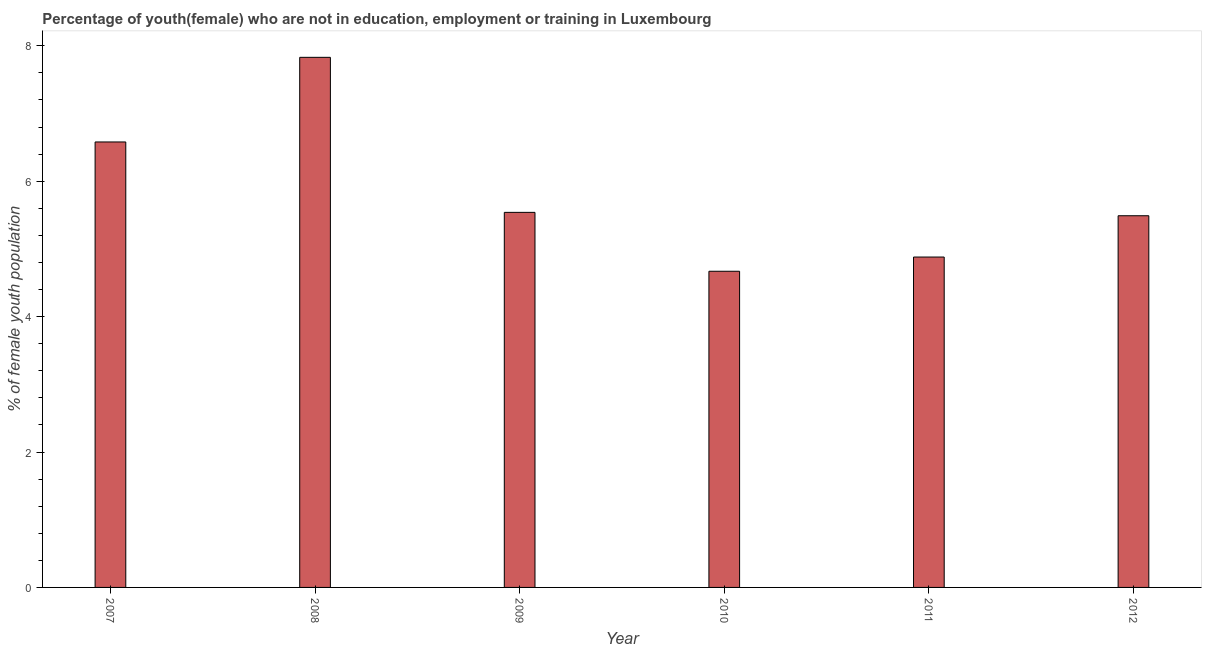Does the graph contain any zero values?
Provide a succinct answer. No. Does the graph contain grids?
Give a very brief answer. No. What is the title of the graph?
Your response must be concise. Percentage of youth(female) who are not in education, employment or training in Luxembourg. What is the label or title of the X-axis?
Offer a very short reply. Year. What is the label or title of the Y-axis?
Give a very brief answer. % of female youth population. What is the unemployed female youth population in 2007?
Provide a short and direct response. 6.58. Across all years, what is the maximum unemployed female youth population?
Offer a terse response. 7.83. Across all years, what is the minimum unemployed female youth population?
Make the answer very short. 4.67. In which year was the unemployed female youth population maximum?
Ensure brevity in your answer.  2008. What is the sum of the unemployed female youth population?
Make the answer very short. 34.99. What is the difference between the unemployed female youth population in 2011 and 2012?
Give a very brief answer. -0.61. What is the average unemployed female youth population per year?
Provide a short and direct response. 5.83. What is the median unemployed female youth population?
Offer a very short reply. 5.51. In how many years, is the unemployed female youth population greater than 3.6 %?
Provide a succinct answer. 6. What is the ratio of the unemployed female youth population in 2009 to that in 2010?
Provide a succinct answer. 1.19. Is the unemployed female youth population in 2008 less than that in 2011?
Ensure brevity in your answer.  No. Is the difference between the unemployed female youth population in 2009 and 2010 greater than the difference between any two years?
Your answer should be very brief. No. What is the difference between the highest and the second highest unemployed female youth population?
Keep it short and to the point. 1.25. What is the difference between the highest and the lowest unemployed female youth population?
Your response must be concise. 3.16. Are all the bars in the graph horizontal?
Provide a short and direct response. No. How many years are there in the graph?
Your answer should be very brief. 6. Are the values on the major ticks of Y-axis written in scientific E-notation?
Offer a terse response. No. What is the % of female youth population in 2007?
Your answer should be very brief. 6.58. What is the % of female youth population of 2008?
Ensure brevity in your answer.  7.83. What is the % of female youth population in 2009?
Make the answer very short. 5.54. What is the % of female youth population in 2010?
Offer a very short reply. 4.67. What is the % of female youth population in 2011?
Ensure brevity in your answer.  4.88. What is the % of female youth population of 2012?
Your answer should be compact. 5.49. What is the difference between the % of female youth population in 2007 and 2008?
Offer a terse response. -1.25. What is the difference between the % of female youth population in 2007 and 2010?
Offer a terse response. 1.91. What is the difference between the % of female youth population in 2007 and 2011?
Provide a short and direct response. 1.7. What is the difference between the % of female youth population in 2007 and 2012?
Give a very brief answer. 1.09. What is the difference between the % of female youth population in 2008 and 2009?
Provide a short and direct response. 2.29. What is the difference between the % of female youth population in 2008 and 2010?
Provide a short and direct response. 3.16. What is the difference between the % of female youth population in 2008 and 2011?
Offer a terse response. 2.95. What is the difference between the % of female youth population in 2008 and 2012?
Provide a succinct answer. 2.34. What is the difference between the % of female youth population in 2009 and 2010?
Provide a succinct answer. 0.87. What is the difference between the % of female youth population in 2009 and 2011?
Your response must be concise. 0.66. What is the difference between the % of female youth population in 2010 and 2011?
Keep it short and to the point. -0.21. What is the difference between the % of female youth population in 2010 and 2012?
Make the answer very short. -0.82. What is the difference between the % of female youth population in 2011 and 2012?
Keep it short and to the point. -0.61. What is the ratio of the % of female youth population in 2007 to that in 2008?
Make the answer very short. 0.84. What is the ratio of the % of female youth population in 2007 to that in 2009?
Provide a short and direct response. 1.19. What is the ratio of the % of female youth population in 2007 to that in 2010?
Offer a terse response. 1.41. What is the ratio of the % of female youth population in 2007 to that in 2011?
Your answer should be compact. 1.35. What is the ratio of the % of female youth population in 2007 to that in 2012?
Your response must be concise. 1.2. What is the ratio of the % of female youth population in 2008 to that in 2009?
Ensure brevity in your answer.  1.41. What is the ratio of the % of female youth population in 2008 to that in 2010?
Your response must be concise. 1.68. What is the ratio of the % of female youth population in 2008 to that in 2011?
Make the answer very short. 1.6. What is the ratio of the % of female youth population in 2008 to that in 2012?
Your response must be concise. 1.43. What is the ratio of the % of female youth population in 2009 to that in 2010?
Your response must be concise. 1.19. What is the ratio of the % of female youth population in 2009 to that in 2011?
Your answer should be very brief. 1.14. What is the ratio of the % of female youth population in 2010 to that in 2011?
Your answer should be compact. 0.96. What is the ratio of the % of female youth population in 2010 to that in 2012?
Offer a terse response. 0.85. What is the ratio of the % of female youth population in 2011 to that in 2012?
Keep it short and to the point. 0.89. 